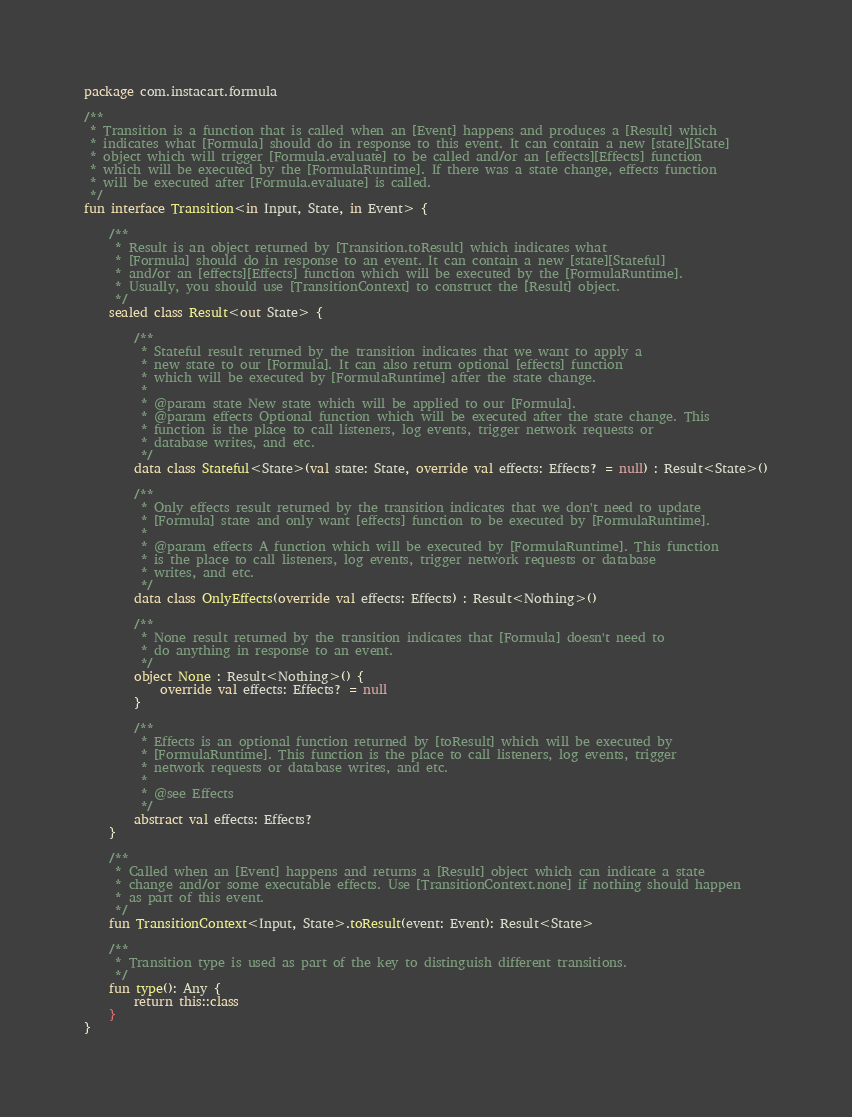Convert code to text. <code><loc_0><loc_0><loc_500><loc_500><_Kotlin_>package com.instacart.formula

/**
 * Transition is a function that is called when an [Event] happens and produces a [Result] which
 * indicates what [Formula] should do in response to this event. It can contain a new [state][State]
 * object which will trigger [Formula.evaluate] to be called and/or an [effects][Effects] function
 * which will be executed by the [FormulaRuntime]. If there was a state change, effects function
 * will be executed after [Formula.evaluate] is called.
 */
fun interface Transition<in Input, State, in Event> {

    /**
     * Result is an object returned by [Transition.toResult] which indicates what
     * [Formula] should do in response to an event. It can contain a new [state][Stateful]
     * and/or an [effects][Effects] function which will be executed by the [FormulaRuntime].
     * Usually, you should use [TransitionContext] to construct the [Result] object.
     */
    sealed class Result<out State> {

        /**
         * Stateful result returned by the transition indicates that we want to apply a
         * new state to our [Formula]. It can also return optional [effects] function
         * which will be executed by [FormulaRuntime] after the state change.
         *
         * @param state New state which will be applied to our [Formula].
         * @param effects Optional function which will be executed after the state change. This
         * function is the place to call listeners, log events, trigger network requests or
         * database writes, and etc.
         */
        data class Stateful<State>(val state: State, override val effects: Effects? = null) : Result<State>()

        /**
         * Only effects result returned by the transition indicates that we don't need to update
         * [Formula] state and only want [effects] function to be executed by [FormulaRuntime].
         *
         * @param effects A function which will be executed by [FormulaRuntime]. This function
         * is the place to call listeners, log events, trigger network requests or database
         * writes, and etc.
         */
        data class OnlyEffects(override val effects: Effects) : Result<Nothing>()

        /**
         * None result returned by the transition indicates that [Formula] doesn't need to
         * do anything in response to an event.
         */
        object None : Result<Nothing>() {
            override val effects: Effects? = null
        }

        /**
         * Effects is an optional function returned by [toResult] which will be executed by
         * [FormulaRuntime]. This function is the place to call listeners, log events, trigger
         * network requests or database writes, and etc.
         *
         * @see Effects
         */
        abstract val effects: Effects?
    }

    /**
     * Called when an [Event] happens and returns a [Result] object which can indicate a state
     * change and/or some executable effects. Use [TransitionContext.none] if nothing should happen
     * as part of this event.
     */
    fun TransitionContext<Input, State>.toResult(event: Event): Result<State>

    /**
     * Transition type is used as part of the key to distinguish different transitions.
     */
    fun type(): Any {
        return this::class
    }
}</code> 